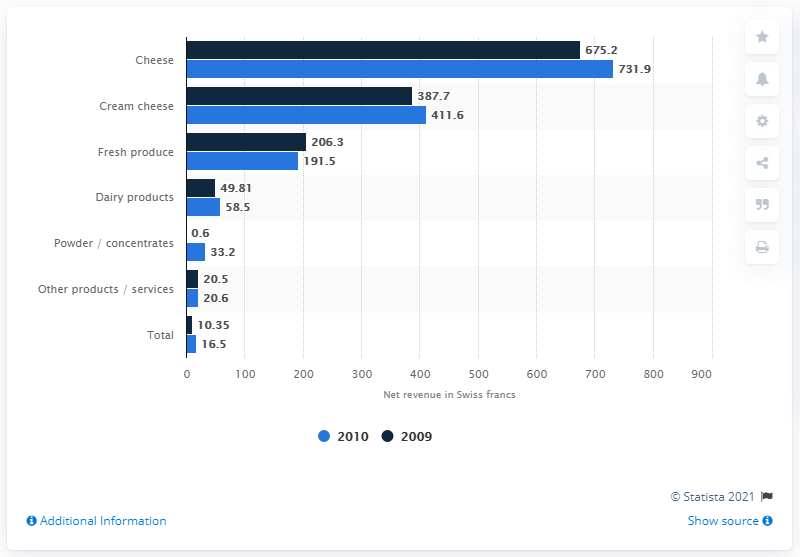Give some essential details in this illustration. In 2009, dairy products contributed approximately 10.35 Swiss francs to the economy. 